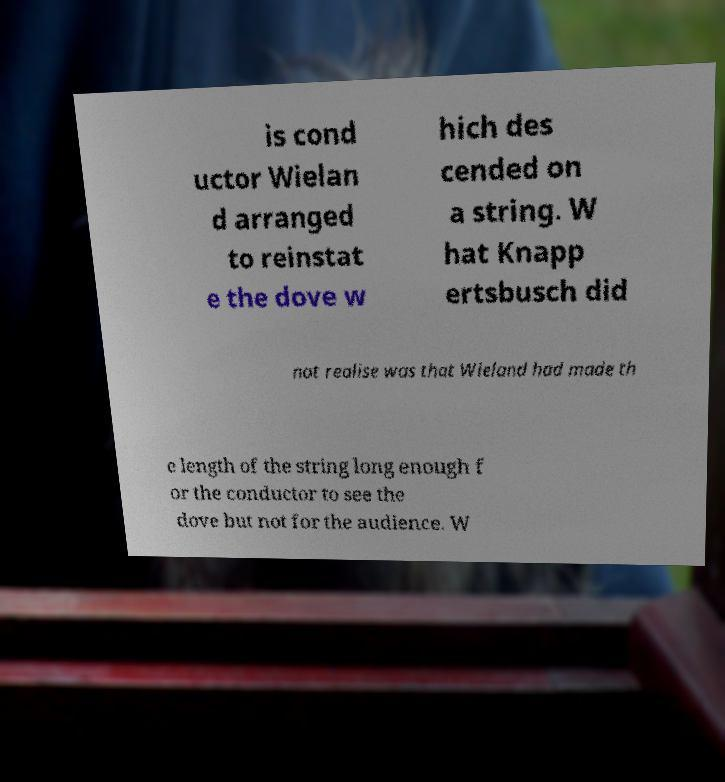What messages or text are displayed in this image? I need them in a readable, typed format. is cond uctor Wielan d arranged to reinstat e the dove w hich des cended on a string. W hat Knapp ertsbusch did not realise was that Wieland had made th e length of the string long enough f or the conductor to see the dove but not for the audience. W 